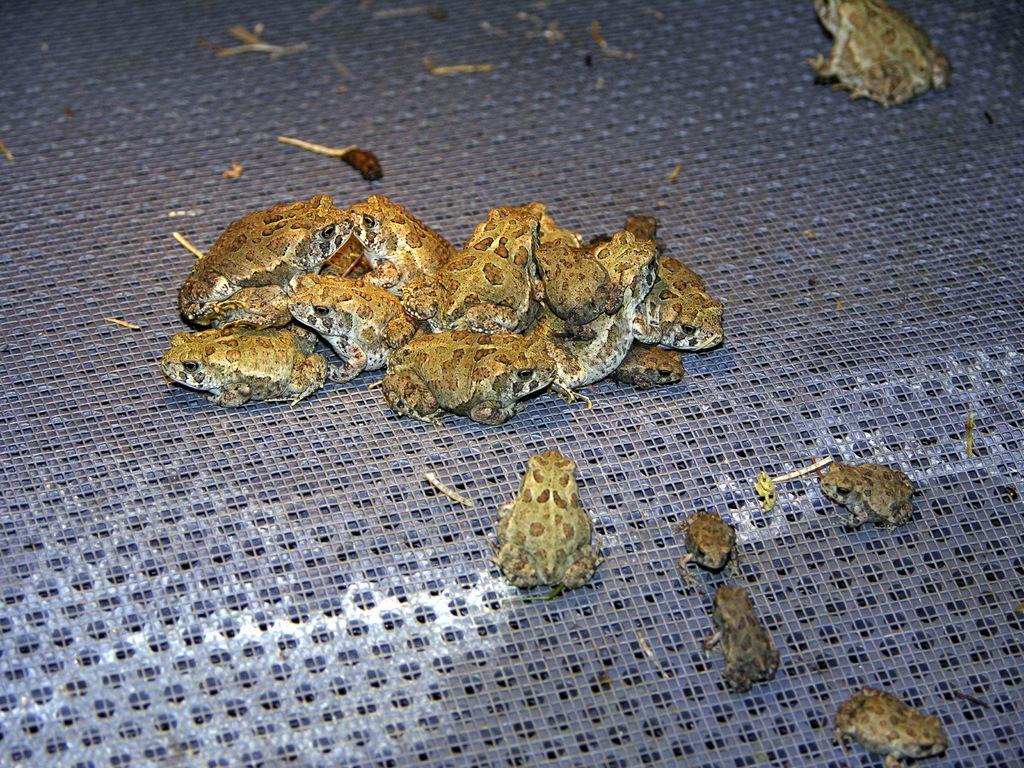How would you summarize this image in a sentence or two? In this picture I can observe some frogs on the floor. These frogs are in brown color. The floor is in purple color. 